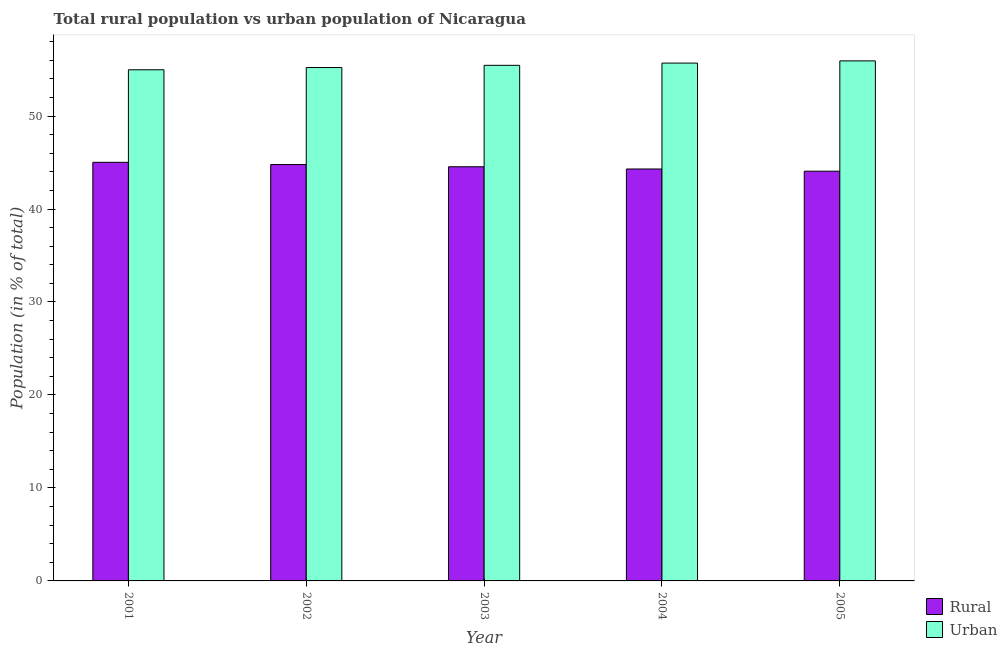How many different coloured bars are there?
Your response must be concise. 2. How many groups of bars are there?
Keep it short and to the point. 5. How many bars are there on the 4th tick from the right?
Offer a terse response. 2. What is the rural population in 2003?
Your response must be concise. 44.55. Across all years, what is the maximum urban population?
Give a very brief answer. 55.93. Across all years, what is the minimum rural population?
Provide a short and direct response. 44.07. In which year was the urban population maximum?
Your response must be concise. 2005. In which year was the urban population minimum?
Make the answer very short. 2001. What is the total urban population in the graph?
Offer a terse response. 277.27. What is the difference between the rural population in 2002 and that in 2005?
Offer a terse response. 0.72. What is the difference between the urban population in 2004 and the rural population in 2002?
Ensure brevity in your answer.  0.48. What is the average urban population per year?
Your answer should be compact. 55.45. In the year 2003, what is the difference between the urban population and rural population?
Give a very brief answer. 0. In how many years, is the rural population greater than 2 %?
Make the answer very short. 5. What is the ratio of the urban population in 2002 to that in 2005?
Ensure brevity in your answer.  0.99. Is the difference between the rural population in 2002 and 2004 greater than the difference between the urban population in 2002 and 2004?
Keep it short and to the point. No. What is the difference between the highest and the second highest urban population?
Offer a very short reply. 0.24. What is the difference between the highest and the lowest rural population?
Keep it short and to the point. 0.96. In how many years, is the rural population greater than the average rural population taken over all years?
Offer a very short reply. 2. What does the 1st bar from the left in 2001 represents?
Your answer should be very brief. Rural. What does the 1st bar from the right in 2003 represents?
Provide a succinct answer. Urban. How many years are there in the graph?
Your answer should be very brief. 5. What is the difference between two consecutive major ticks on the Y-axis?
Your answer should be compact. 10. Are the values on the major ticks of Y-axis written in scientific E-notation?
Offer a very short reply. No. Does the graph contain any zero values?
Offer a very short reply. No. Does the graph contain grids?
Keep it short and to the point. No. How are the legend labels stacked?
Offer a very short reply. Vertical. What is the title of the graph?
Offer a terse response. Total rural population vs urban population of Nicaragua. Does "Under-5(male)" appear as one of the legend labels in the graph?
Offer a terse response. No. What is the label or title of the Y-axis?
Give a very brief answer. Population (in % of total). What is the Population (in % of total) of Rural in 2001?
Ensure brevity in your answer.  45.02. What is the Population (in % of total) in Urban in 2001?
Your answer should be compact. 54.98. What is the Population (in % of total) in Rural in 2002?
Make the answer very short. 44.78. What is the Population (in % of total) of Urban in 2002?
Your answer should be compact. 55.22. What is the Population (in % of total) of Rural in 2003?
Your answer should be very brief. 44.55. What is the Population (in % of total) of Urban in 2003?
Keep it short and to the point. 55.45. What is the Population (in % of total) of Rural in 2004?
Give a very brief answer. 44.3. What is the Population (in % of total) of Urban in 2004?
Your response must be concise. 55.7. What is the Population (in % of total) of Rural in 2005?
Your answer should be very brief. 44.07. What is the Population (in % of total) of Urban in 2005?
Ensure brevity in your answer.  55.93. Across all years, what is the maximum Population (in % of total) of Rural?
Your answer should be compact. 45.02. Across all years, what is the maximum Population (in % of total) of Urban?
Your answer should be very brief. 55.93. Across all years, what is the minimum Population (in % of total) of Rural?
Provide a succinct answer. 44.07. Across all years, what is the minimum Population (in % of total) of Urban?
Provide a short and direct response. 54.98. What is the total Population (in % of total) in Rural in the graph?
Ensure brevity in your answer.  222.72. What is the total Population (in % of total) of Urban in the graph?
Your response must be concise. 277.27. What is the difference between the Population (in % of total) of Rural in 2001 and that in 2002?
Offer a terse response. 0.24. What is the difference between the Population (in % of total) of Urban in 2001 and that in 2002?
Offer a very short reply. -0.24. What is the difference between the Population (in % of total) of Rural in 2001 and that in 2003?
Make the answer very short. 0.48. What is the difference between the Population (in % of total) of Urban in 2001 and that in 2003?
Your response must be concise. -0.48. What is the difference between the Population (in % of total) in Rural in 2001 and that in 2004?
Offer a very short reply. 0.72. What is the difference between the Population (in % of total) of Urban in 2001 and that in 2004?
Provide a short and direct response. -0.72. What is the difference between the Population (in % of total) of Urban in 2001 and that in 2005?
Provide a short and direct response. -0.96. What is the difference between the Population (in % of total) of Rural in 2002 and that in 2003?
Your answer should be compact. 0.24. What is the difference between the Population (in % of total) of Urban in 2002 and that in 2003?
Make the answer very short. -0.24. What is the difference between the Population (in % of total) in Rural in 2002 and that in 2004?
Give a very brief answer. 0.48. What is the difference between the Population (in % of total) in Urban in 2002 and that in 2004?
Provide a succinct answer. -0.48. What is the difference between the Population (in % of total) in Rural in 2002 and that in 2005?
Keep it short and to the point. 0.72. What is the difference between the Population (in % of total) of Urban in 2002 and that in 2005?
Provide a short and direct response. -0.72. What is the difference between the Population (in % of total) in Rural in 2003 and that in 2004?
Your response must be concise. 0.24. What is the difference between the Population (in % of total) in Urban in 2003 and that in 2004?
Offer a terse response. -0.24. What is the difference between the Population (in % of total) in Rural in 2003 and that in 2005?
Your answer should be compact. 0.48. What is the difference between the Population (in % of total) of Urban in 2003 and that in 2005?
Your answer should be compact. -0.48. What is the difference between the Population (in % of total) of Rural in 2004 and that in 2005?
Offer a terse response. 0.24. What is the difference between the Population (in % of total) in Urban in 2004 and that in 2005?
Offer a terse response. -0.24. What is the difference between the Population (in % of total) in Rural in 2001 and the Population (in % of total) in Urban in 2002?
Make the answer very short. -10.19. What is the difference between the Population (in % of total) of Rural in 2001 and the Population (in % of total) of Urban in 2003?
Make the answer very short. -10.43. What is the difference between the Population (in % of total) in Rural in 2001 and the Population (in % of total) in Urban in 2004?
Offer a terse response. -10.67. What is the difference between the Population (in % of total) in Rural in 2001 and the Population (in % of total) in Urban in 2005?
Your answer should be compact. -10.91. What is the difference between the Population (in % of total) in Rural in 2002 and the Population (in % of total) in Urban in 2003?
Provide a succinct answer. -10.67. What is the difference between the Population (in % of total) of Rural in 2002 and the Population (in % of total) of Urban in 2004?
Provide a short and direct response. -10.91. What is the difference between the Population (in % of total) in Rural in 2002 and the Population (in % of total) in Urban in 2005?
Provide a short and direct response. -11.15. What is the difference between the Population (in % of total) in Rural in 2003 and the Population (in % of total) in Urban in 2004?
Keep it short and to the point. -11.15. What is the difference between the Population (in % of total) in Rural in 2003 and the Population (in % of total) in Urban in 2005?
Provide a succinct answer. -11.39. What is the difference between the Population (in % of total) in Rural in 2004 and the Population (in % of total) in Urban in 2005?
Your answer should be very brief. -11.63. What is the average Population (in % of total) in Rural per year?
Ensure brevity in your answer.  44.55. What is the average Population (in % of total) of Urban per year?
Offer a very short reply. 55.45. In the year 2001, what is the difference between the Population (in % of total) in Rural and Population (in % of total) in Urban?
Offer a terse response. -9.95. In the year 2002, what is the difference between the Population (in % of total) in Rural and Population (in % of total) in Urban?
Keep it short and to the point. -10.43. In the year 2003, what is the difference between the Population (in % of total) of Rural and Population (in % of total) of Urban?
Provide a short and direct response. -10.91. In the year 2004, what is the difference between the Population (in % of total) in Rural and Population (in % of total) in Urban?
Your answer should be very brief. -11.39. In the year 2005, what is the difference between the Population (in % of total) of Rural and Population (in % of total) of Urban?
Ensure brevity in your answer.  -11.87. What is the ratio of the Population (in % of total) in Rural in 2001 to that in 2002?
Your answer should be compact. 1.01. What is the ratio of the Population (in % of total) in Urban in 2001 to that in 2002?
Offer a terse response. 1. What is the ratio of the Population (in % of total) in Rural in 2001 to that in 2003?
Your response must be concise. 1.01. What is the ratio of the Population (in % of total) in Urban in 2001 to that in 2003?
Keep it short and to the point. 0.99. What is the ratio of the Population (in % of total) of Rural in 2001 to that in 2004?
Provide a short and direct response. 1.02. What is the ratio of the Population (in % of total) in Urban in 2001 to that in 2004?
Provide a short and direct response. 0.99. What is the ratio of the Population (in % of total) of Rural in 2001 to that in 2005?
Give a very brief answer. 1.02. What is the ratio of the Population (in % of total) in Urban in 2001 to that in 2005?
Make the answer very short. 0.98. What is the ratio of the Population (in % of total) of Rural in 2002 to that in 2003?
Your answer should be compact. 1.01. What is the ratio of the Population (in % of total) in Urban in 2002 to that in 2003?
Offer a very short reply. 1. What is the ratio of the Population (in % of total) in Rural in 2002 to that in 2004?
Make the answer very short. 1.01. What is the ratio of the Population (in % of total) in Urban in 2002 to that in 2004?
Provide a short and direct response. 0.99. What is the ratio of the Population (in % of total) in Rural in 2002 to that in 2005?
Give a very brief answer. 1.02. What is the ratio of the Population (in % of total) in Urban in 2002 to that in 2005?
Your answer should be very brief. 0.99. What is the ratio of the Population (in % of total) in Rural in 2003 to that in 2004?
Give a very brief answer. 1.01. What is the ratio of the Population (in % of total) in Rural in 2003 to that in 2005?
Offer a very short reply. 1.01. What is the ratio of the Population (in % of total) in Rural in 2004 to that in 2005?
Ensure brevity in your answer.  1.01. What is the ratio of the Population (in % of total) of Urban in 2004 to that in 2005?
Your answer should be very brief. 1. What is the difference between the highest and the second highest Population (in % of total) of Rural?
Make the answer very short. 0.24. What is the difference between the highest and the second highest Population (in % of total) of Urban?
Provide a succinct answer. 0.24. What is the difference between the highest and the lowest Population (in % of total) in Rural?
Provide a short and direct response. 0.96. What is the difference between the highest and the lowest Population (in % of total) in Urban?
Ensure brevity in your answer.  0.96. 